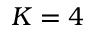Convert formula to latex. <formula><loc_0><loc_0><loc_500><loc_500>K = 4</formula> 